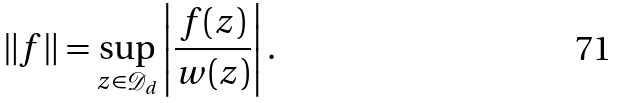<formula> <loc_0><loc_0><loc_500><loc_500>\| f \| = \sup _ { z \in \mathcal { D } _ { d } } \left | \frac { f ( z ) } { w ( z ) } \right | .</formula> 